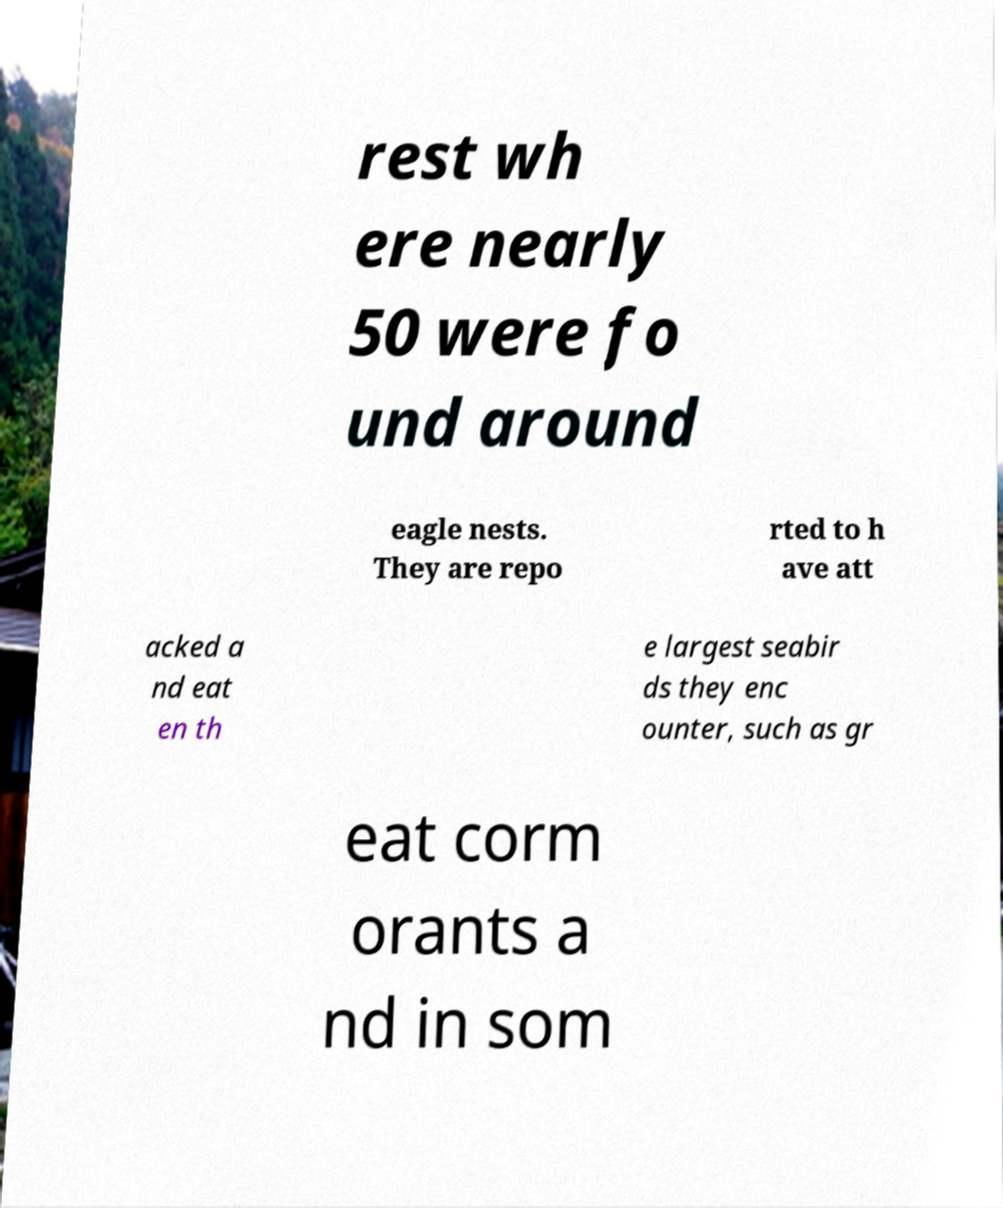There's text embedded in this image that I need extracted. Can you transcribe it verbatim? rest wh ere nearly 50 were fo und around eagle nests. They are repo rted to h ave att acked a nd eat en th e largest seabir ds they enc ounter, such as gr eat corm orants a nd in som 